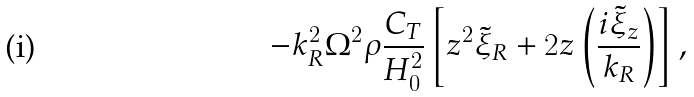Convert formula to latex. <formula><loc_0><loc_0><loc_500><loc_500>- k ^ { 2 } _ { R } \Omega ^ { 2 } \rho \frac { C _ { T } } { H ^ { 2 } _ { 0 } } \left [ z ^ { 2 } \tilde { \xi } _ { R } + 2 z \left ( \frac { i \tilde { \xi } _ { z } } { k _ { R } } \right ) \right ] ,</formula> 